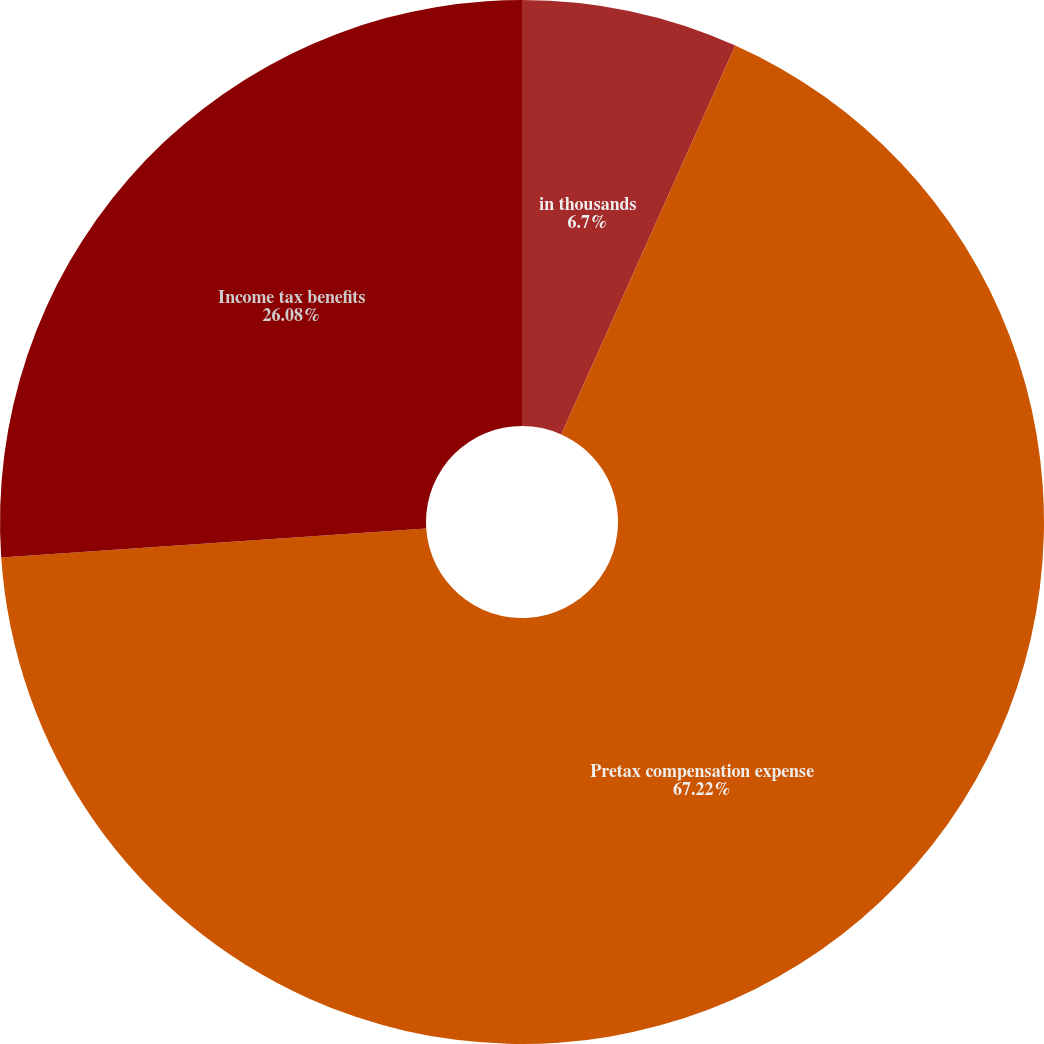<chart> <loc_0><loc_0><loc_500><loc_500><pie_chart><fcel>in thousands<fcel>Pretax compensation expense<fcel>Income tax benefits<nl><fcel>6.7%<fcel>67.22%<fcel>26.08%<nl></chart> 